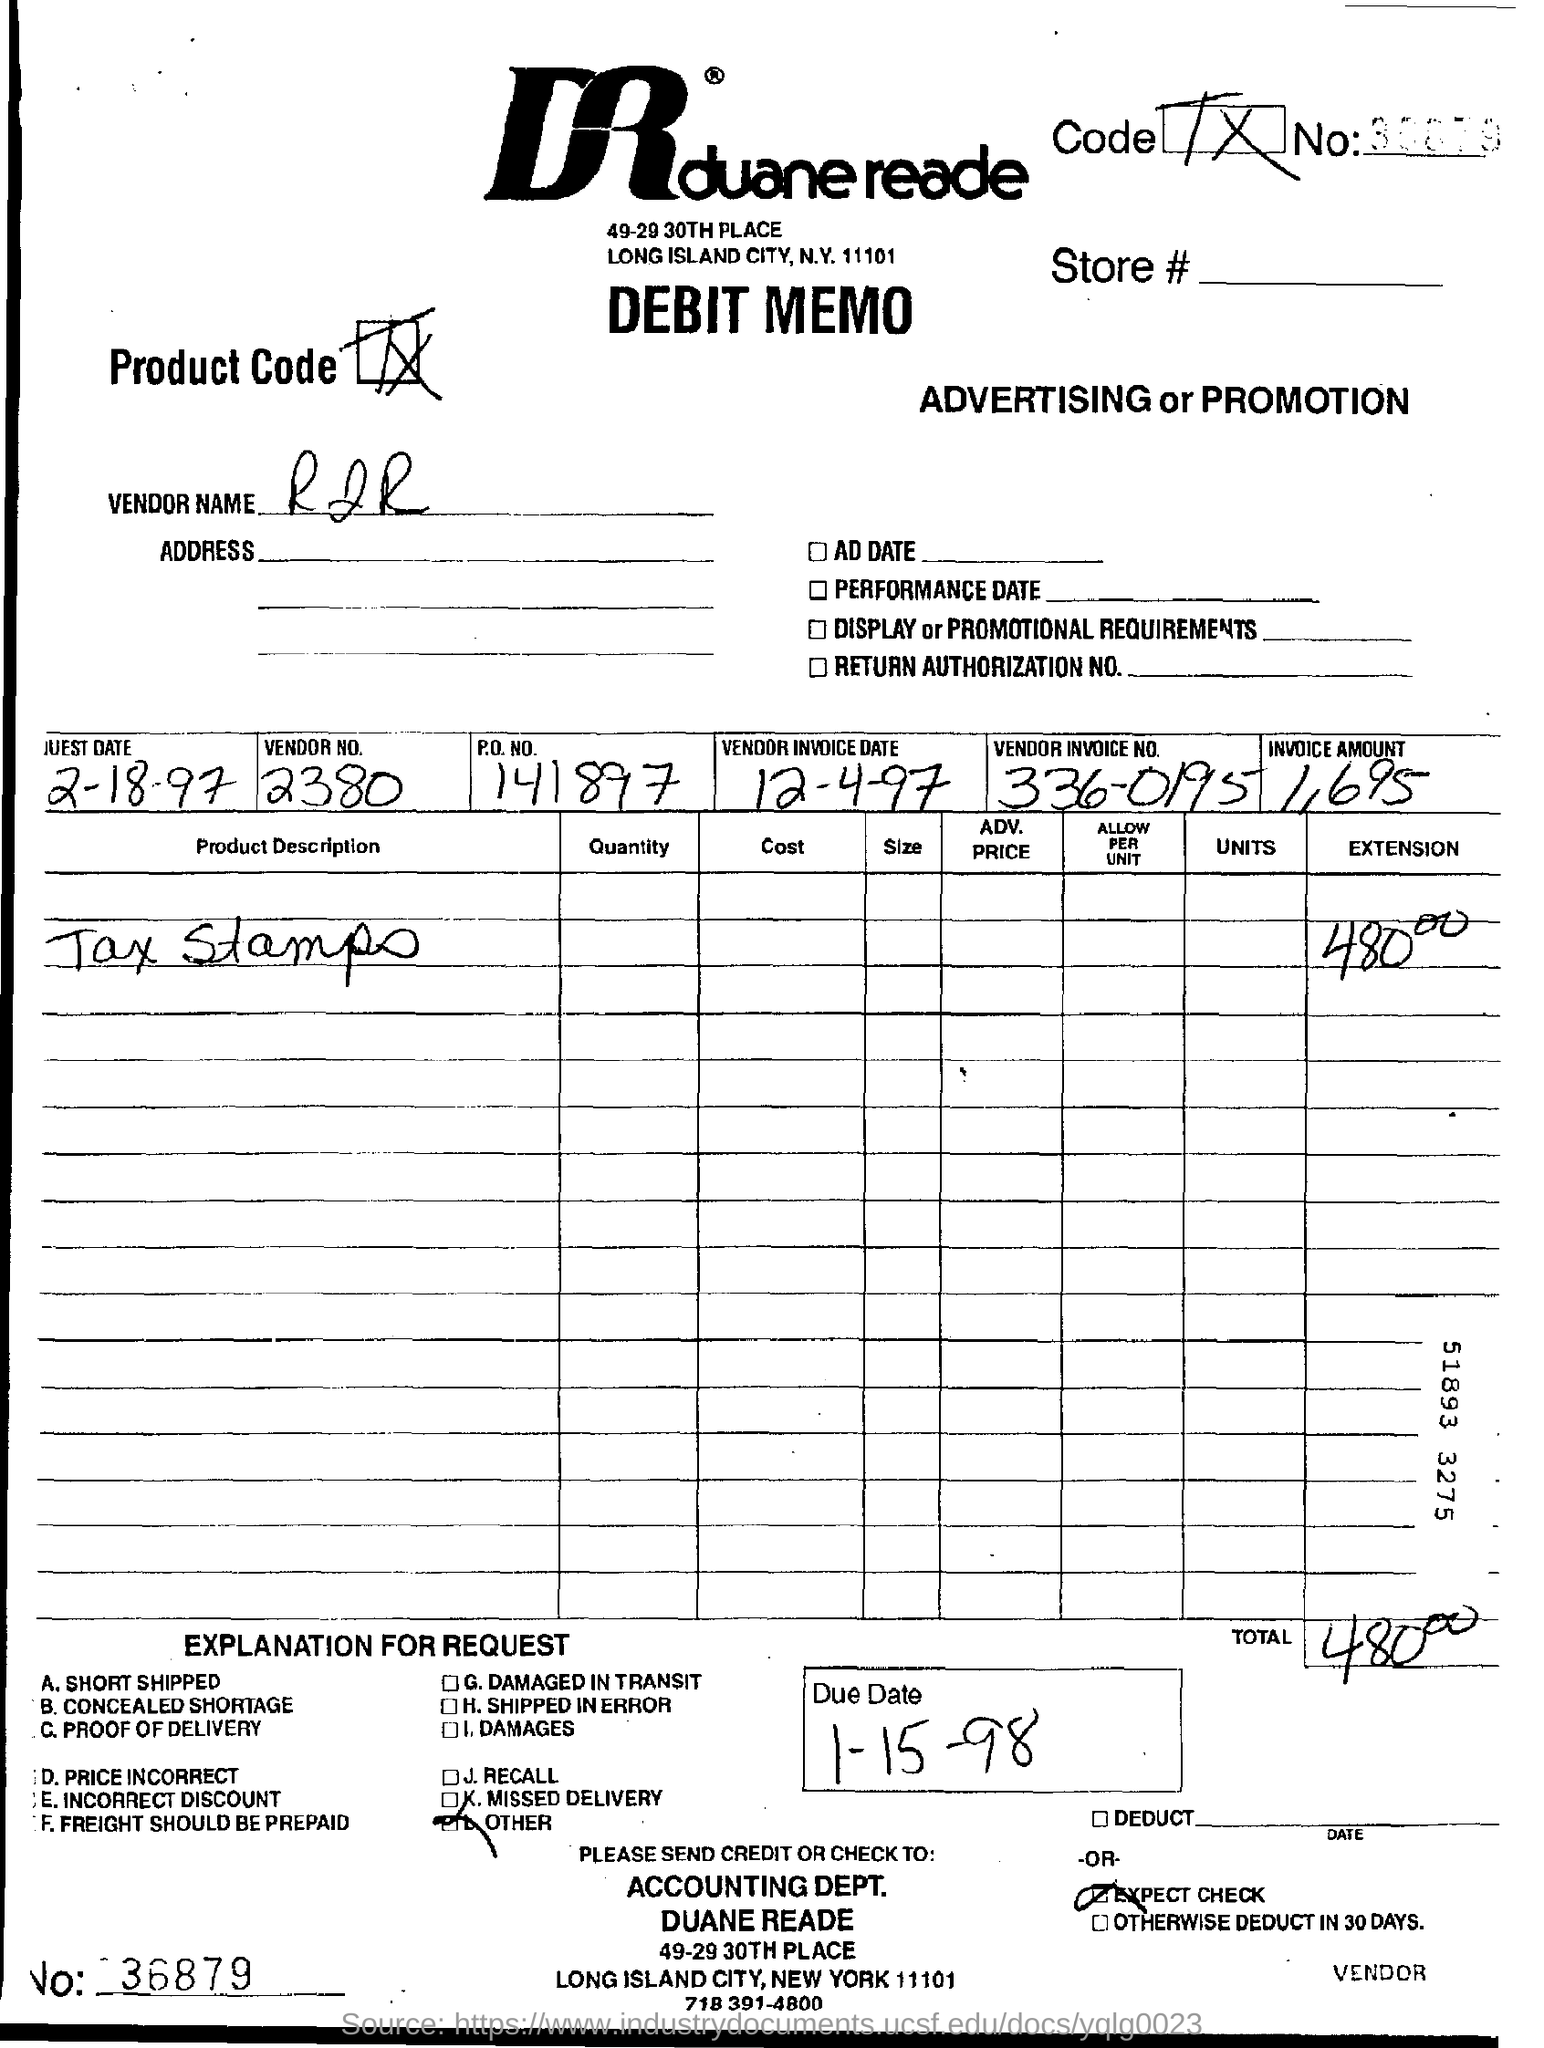Can you tell me what kind of document is shown in the image? The image shows a 'Debit Memo' from Duane Reade. It's a financial document typically issued by a buyer to a seller to reflect a debit made on the seller's account, often for advertising or promotional services rendered.  What specific details can you provide about the transaction mentioned in the memo? The memo includes details such as the vendor number, PO number, product description, quantity, cost, and a total amount of $480. There is also a due date listed for 1-15-98, indicating that the document is from 1997/1998. This suggests it is an archival document, possibly for accounting or historical reference. 